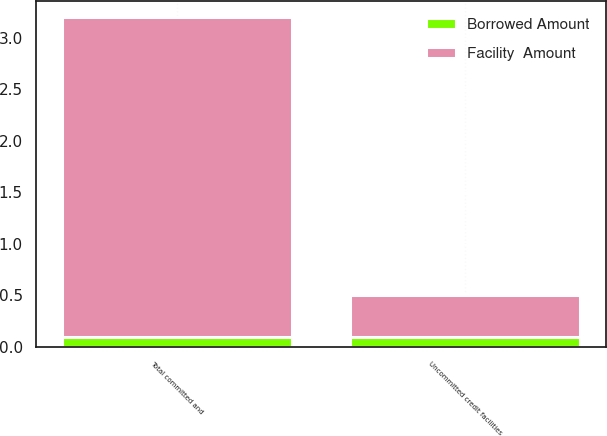<chart> <loc_0><loc_0><loc_500><loc_500><stacked_bar_chart><ecel><fcel>Uncommitted credit facilities<fcel>Total committed and<nl><fcel>Facility  Amount<fcel>0.4<fcel>3.1<nl><fcel>Borrowed Amount<fcel>0.1<fcel>0.1<nl></chart> 